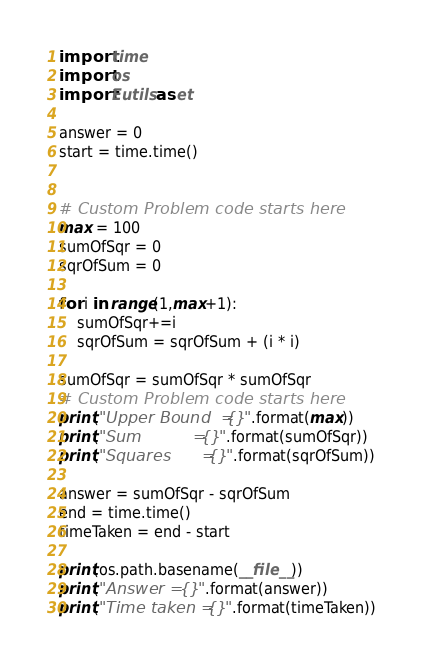<code> <loc_0><loc_0><loc_500><loc_500><_Python_>import time
import os
import Eutils as et

answer = 0
start = time.time()


# Custom Problem code starts here
max = 100
sumOfSqr = 0
sqrOfSum = 0

for i in range(1,max+1):
	sumOfSqr+=i
	sqrOfSum = sqrOfSum + (i * i)

sumOfSqr = sumOfSqr * sumOfSqr
# Custom Problem code starts here
print("Upper Bound  = {}".format(max))
print("Sum          = {}".format(sumOfSqr))
print("Squares      = {}".format(sqrOfSum))

answer = sumOfSqr - sqrOfSum
end = time.time()
timeTaken = end - start

print(os.path.basename(__file__))
print("Answer = {}".format(answer))
print("Time taken = {}".format(timeTaken))
</code> 